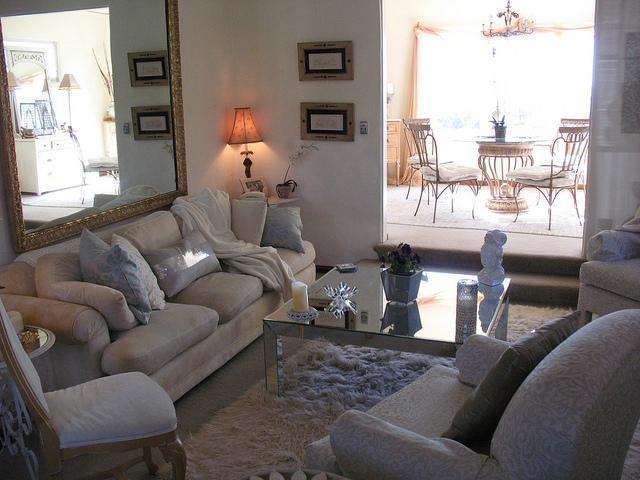How many rooms are shown in the picture?
Give a very brief answer. 3. How many chairs are in the picture?
Give a very brief answer. 5. How many blue lanterns are hanging on the left side of the banana bunches?
Give a very brief answer. 0. 